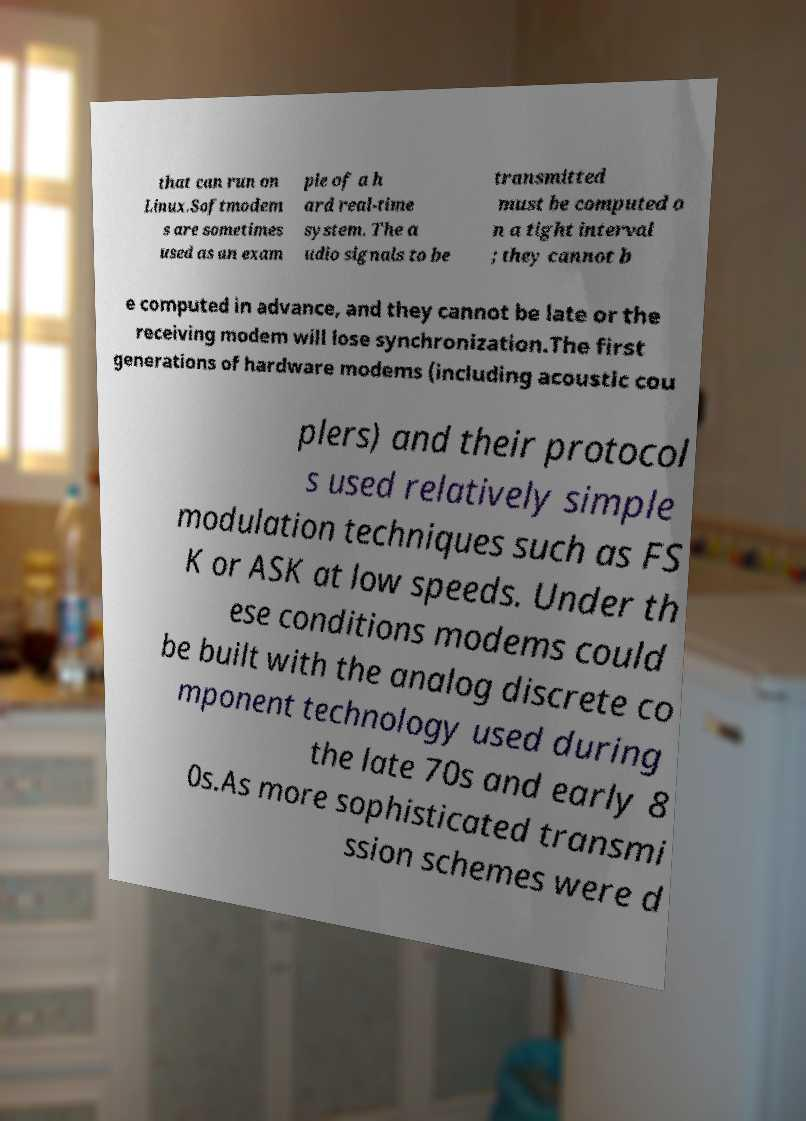What messages or text are displayed in this image? I need them in a readable, typed format. that can run on Linux.Softmodem s are sometimes used as an exam ple of a h ard real-time system. The a udio signals to be transmitted must be computed o n a tight interval ; they cannot b e computed in advance, and they cannot be late or the receiving modem will lose synchronization.The first generations of hardware modems (including acoustic cou plers) and their protocol s used relatively simple modulation techniques such as FS K or ASK at low speeds. Under th ese conditions modems could be built with the analog discrete co mponent technology used during the late 70s and early 8 0s.As more sophisticated transmi ssion schemes were d 